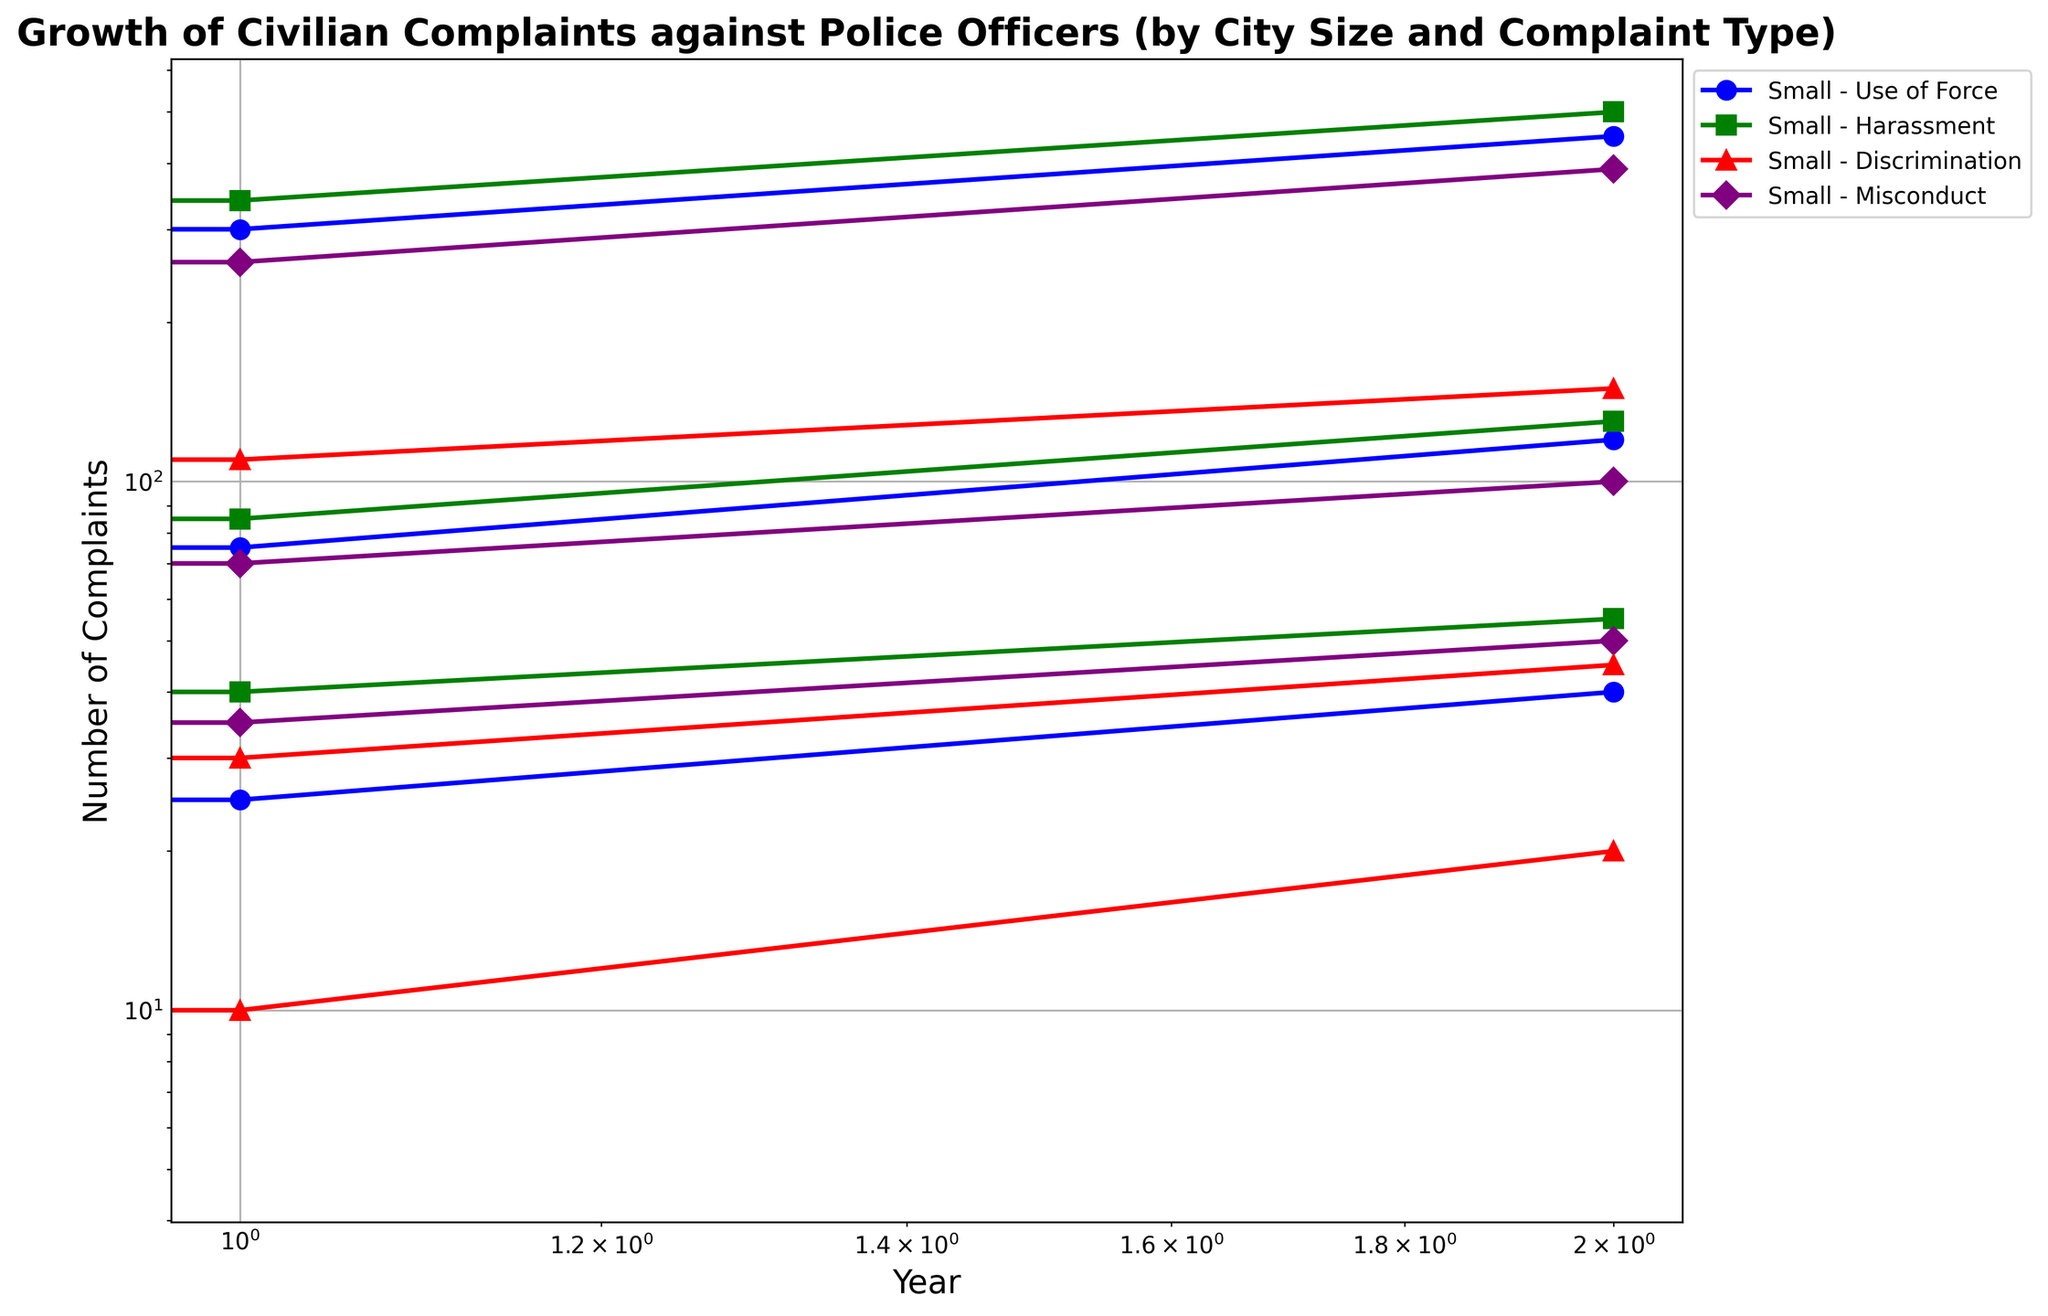Which city size experienced the highest growth in 'Use of Force' complaints from 2010 to 2020? To determine the highest growth in 'Use of Force' complaints across city sizes, we look at the complaints for 2010 and 2020 for small, medium, and large cities: Small (15 to 40), Medium (50 to 120), Large (200 to 450). Calculate the growth by subtracting 2010 values from 2020 values: Small (40-15=25), Medium (120-50=70), Large (450-200=250). The Large city size has the highest growth at 250 complaints.
Answer: Large Which complaint type showed the smallest increase in small cities from 2010 to 2020? To identify the smallest increase for small cities, we look at the growth for each complaint type: Use of Force (15 to 40 → 25), Harassment (30 to 55 → 25), Discrimination (5 to 20 → 15), Misconduct (20 to 50 → 30). The smallest increase is seen in Discrimination (15).
Answer: Discrimination Between medium and large cities, which had more complaints for 'Harassment' in 2015? Compare the 'Harassment' complaints for medium and large cities in 2015: Medium (85), Large (340). Clearly, large cities had more complaints in 2015.
Answer: Large On the log scale, which complaint type in large cities showed the most significant increase between any two consecutive periods? Compare the increase between years for each complaint type in large cities: Use of Force (200 to 300 → 50%, 300 to 450 → 50%), Harassment (220 to 340 → 54.5%, 340 to 500 → 47%), Discrimination (80 to 110 → 37.5%, 110 to 150 → 36.4%), Misconduct (180 to 260 → 44.4%, 260 to 390 → 50%). 'Harassment' showed the most significant increase between 2010-2015 at 54.5%.
Answer: Harassment (2010-2015) Which city size has the most consistent trend for 'Misconduct' complaints across the three years? Assess consistency by comparing the changes in 'Misconduct' complaints for each city size: Small (20 to 35 → 15, 35 to 50 → 15), Medium (45 to 70 → 25, 70 to 100 → 30), Large (180 to 260 → 80, 260 to 390 → 130). The most consistent trend is seen in small cities, where the growth remains consistent at 15 each period.
Answer: Small What color represents 'Discrimination' complaints in the figure? By examining the color coding used for different complaint types, we find that 'Discrimination' complaints are represented in red.
Answer: Red How do 'Harassment' complaints in medium cities compare visually to 'Harassment' complaints in large cities in 2020? Refer to the visual attributes: Medium city 'Harassment' complaints have fewer markers (dots) and are lower on the y-axis compared to large city 'Harassment' complaints, indicating fewer complaints.
Answer: Fewer and lower Among all complaint types in small cities, which had the largest number in 2020? For small cities in 2020, compare the number of complaints: Use of Force (40), Harassment (55), Discrimination (20), Misconduct (50). The largest number is in 'Harassment' with 55 complaints.
Answer: Harassment 